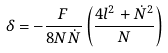<formula> <loc_0><loc_0><loc_500><loc_500>\delta = - \frac { F } { 8 N \dot { N } } \left ( \frac { 4 l ^ { 2 } + \dot { N } ^ { 2 } } { N } \right ) ^ { }</formula> 